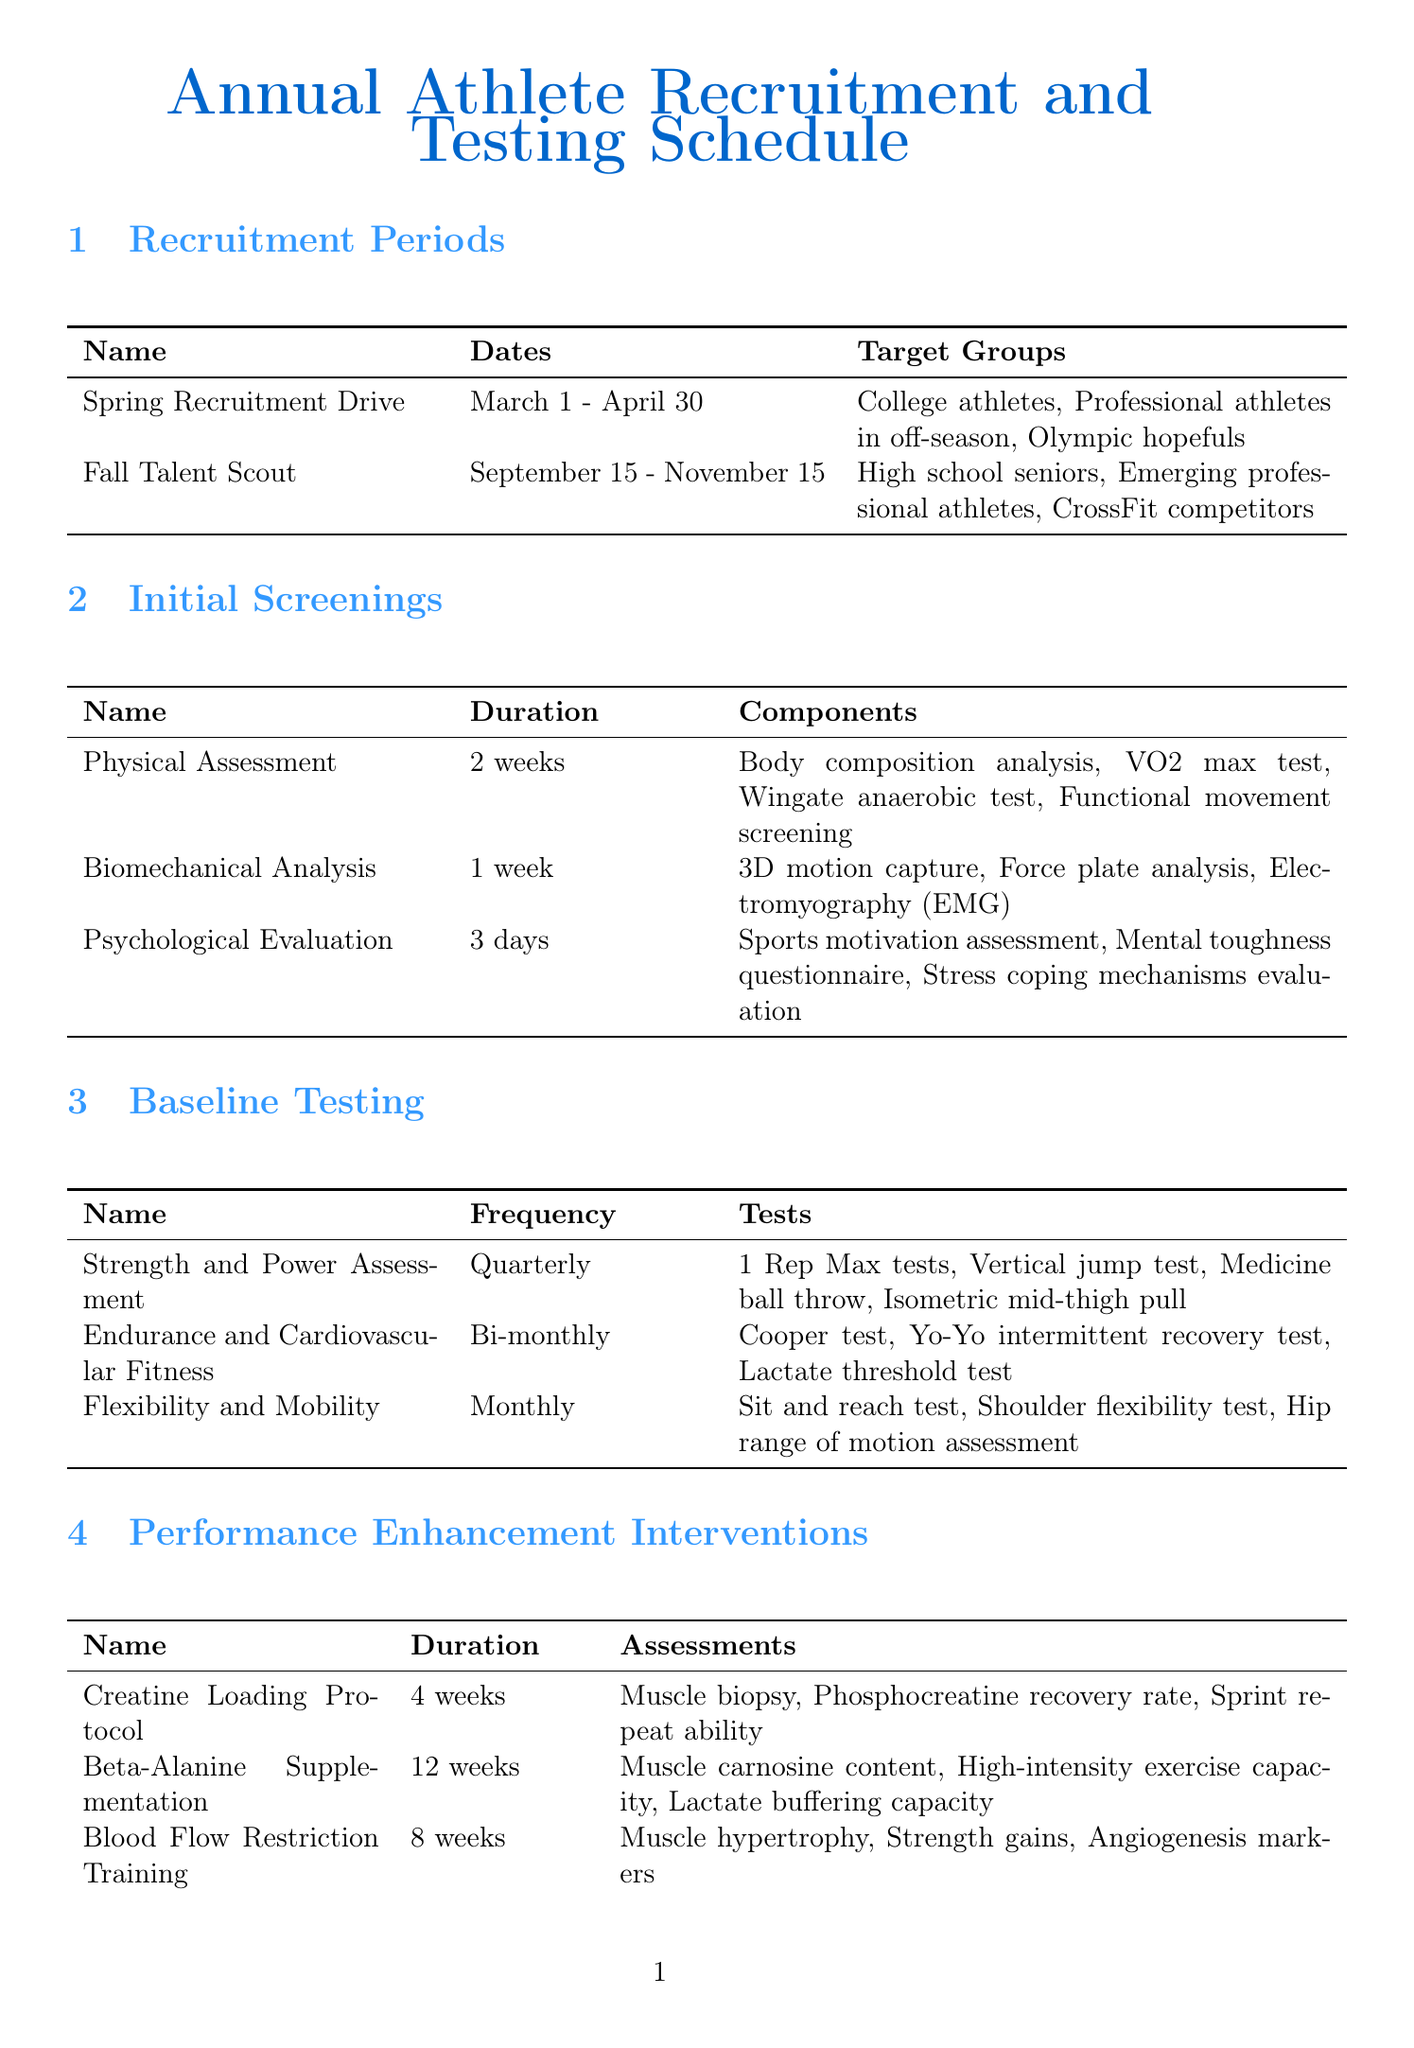What is the duration of the Spring Recruitment Drive? The duration of the Spring Recruitment Drive is specified as March 1 to April 30, which makes it 2 months.
Answer: 2 months How many components are included in the Physical Assessment screening? The Physical Assessment includes four components: body composition analysis, VO2 max test, Wingate anaerobic test, and functional movement screening.
Answer: Four What is the frequency of the Strength and Power Assessment? The frequency of the Strength and Power Assessment is listed as quarterly.
Answer: Quarterly Which performance enhancement intervention lasts the longest? The document lists Beta-Alanine Supplementation as lasting 12 weeks, which is the longest duration among the interventions.
Answer: 12 weeks What measurements are taken for the Cryotherapy vs. Contrast Water Therapy trial? The measurements include inflammatory markers, muscle soreness ratings, and range of motion recovery.
Answer: Inflammatory markers, muscle soreness ratings, range of motion recovery What is the focus of the Annual Performance Report? The focus areas for the Annual Performance Report include yearly athlete improvements, comparative analysis of interventions, and research publication preparation.
Answer: Yearly athlete improvements, comparative analysis of interventions, research publication preparation During which period are recovery protocol trials conducted? Trials for recovery protocols such as cryotherapy are conducted over specific durations either lasting weeks or days, specifically during the mentioned trial periods.
Answer: 2 weeks to 6 weeks Which athlete category is targeted during the Fall Talent Scout? The targeted athlete categories during the Fall Talent Scout include high school seniors and emerging professional athletes.
Answer: High school seniors and emerging professional athletes 